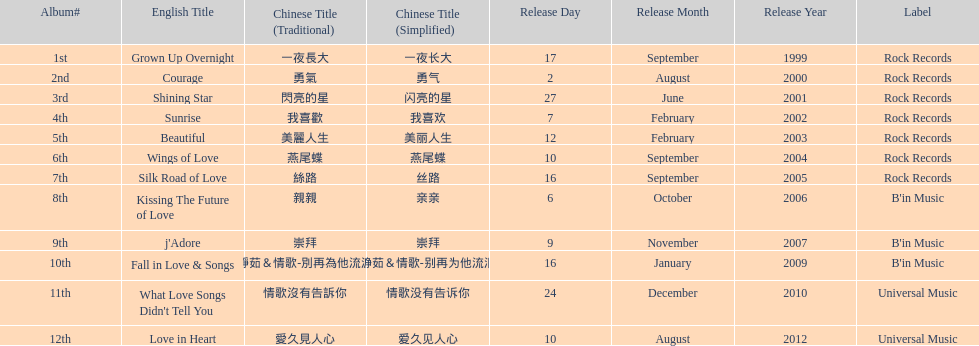Was the album beautiful released before the album love in heart? Yes. Write the full table. {'header': ['Album#', 'English Title', 'Chinese Title (Traditional)', 'Chinese Title (Simplified)', 'Release Day', 'Release Month', 'Release Year', 'Label'], 'rows': [['1st', 'Grown Up Overnight', '一夜長大', '一夜长大', '17', 'September', '1999', 'Rock Records'], ['2nd', 'Courage', '勇氣', '勇气', '2', 'August', '2000', 'Rock Records'], ['3rd', 'Shining Star', '閃亮的星', '闪亮的星', '27', 'June', '2001', 'Rock Records'], ['4th', 'Sunrise', '我喜歡', '我喜欢', '7', 'February', '2002', 'Rock Records'], ['5th', 'Beautiful', '美麗人生', '美丽人生', '12', 'February', '2003', 'Rock Records'], ['6th', 'Wings of Love', '燕尾蝶', '燕尾蝶', '10', 'September', '2004', 'Rock Records'], ['7th', 'Silk Road of Love', '絲路', '丝路', '16', 'September', '2005', 'Rock Records'], ['8th', 'Kissing The Future of Love', '親親', '亲亲', '6', 'October', '2006', "B'in Music"], ['9th', "j'Adore", '崇拜', '崇拜', '9', 'November', '2007', "B'in Music"], ['10th', 'Fall in Love & Songs', '靜茹＆情歌-別再為他流淚', '静茹＆情歌-别再为他流泪', '16', 'January', '2009', "B'in Music"], ['11th', "What Love Songs Didn't Tell You", '情歌沒有告訴你', '情歌没有告诉你', '24', 'December', '2010', 'Universal Music'], ['12th', 'Love in Heart', '愛久見人心', '爱久见人心', '10', 'August', '2012', 'Universal Music']]} 